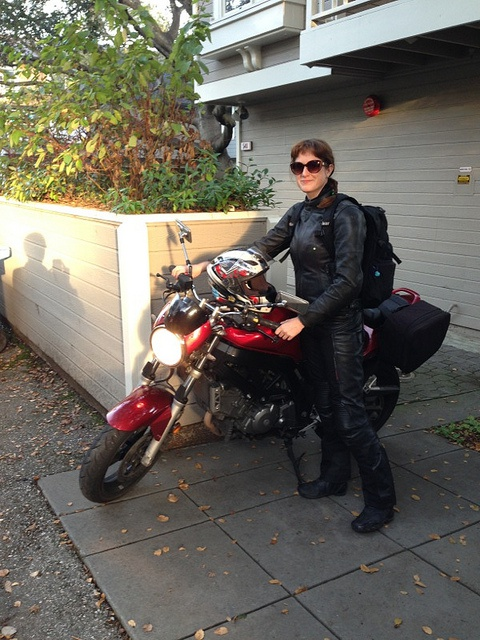Describe the objects in this image and their specific colors. I can see motorcycle in gray, black, maroon, and white tones, people in gray, black, and tan tones, and backpack in gray, black, darkgray, and teal tones in this image. 